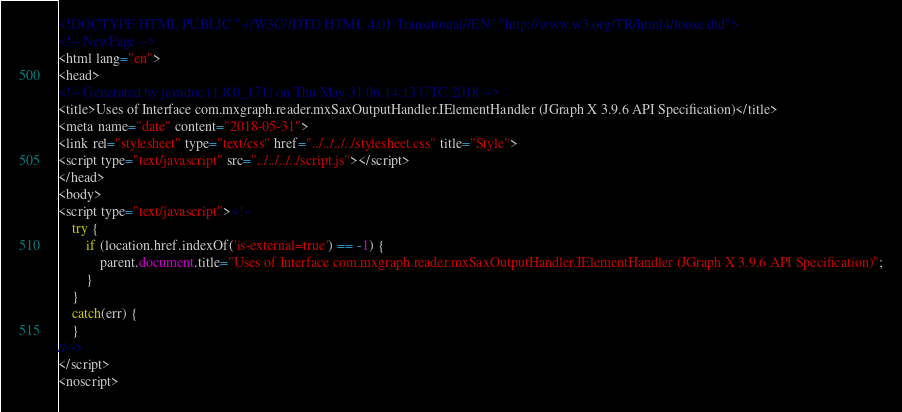<code> <loc_0><loc_0><loc_500><loc_500><_HTML_><!DOCTYPE HTML PUBLIC "-//W3C//DTD HTML 4.01 Transitional//EN" "http://www.w3.org/TR/html4/loose.dtd">
<!-- NewPage -->
<html lang="en">
<head>
<!-- Generated by javadoc (1.8.0_171) on Thu May 31 06:14:13 UTC 2018 -->
<title>Uses of Interface com.mxgraph.reader.mxSaxOutputHandler.IElementHandler (JGraph X 3.9.6 API Specification)</title>
<meta name="date" content="2018-05-31">
<link rel="stylesheet" type="text/css" href="../../../../stylesheet.css" title="Style">
<script type="text/javascript" src="../../../../script.js"></script>
</head>
<body>
<script type="text/javascript"><!--
    try {
        if (location.href.indexOf('is-external=true') == -1) {
            parent.document.title="Uses of Interface com.mxgraph.reader.mxSaxOutputHandler.IElementHandler (JGraph X 3.9.6 API Specification)";
        }
    }
    catch(err) {
    }
//-->
</script>
<noscript></code> 